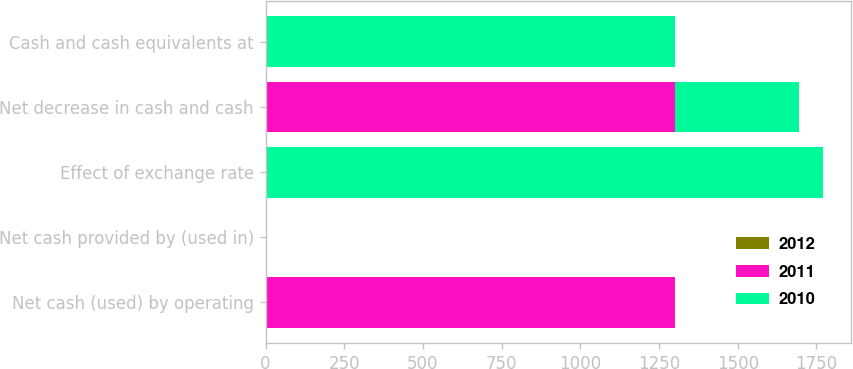<chart> <loc_0><loc_0><loc_500><loc_500><stacked_bar_chart><ecel><fcel>Net cash (used) by operating<fcel>Net cash provided by (used in)<fcel>Effect of exchange rate<fcel>Net decrease in cash and cash<fcel>Cash and cash equivalents at<nl><fcel>2012<fcel>0<fcel>0<fcel>0<fcel>0<fcel>0<nl><fcel>2011<fcel>1301<fcel>0<fcel>0<fcel>1301<fcel>0<nl><fcel>2010<fcel>0<fcel>0<fcel>1771<fcel>393<fcel>1301<nl></chart> 